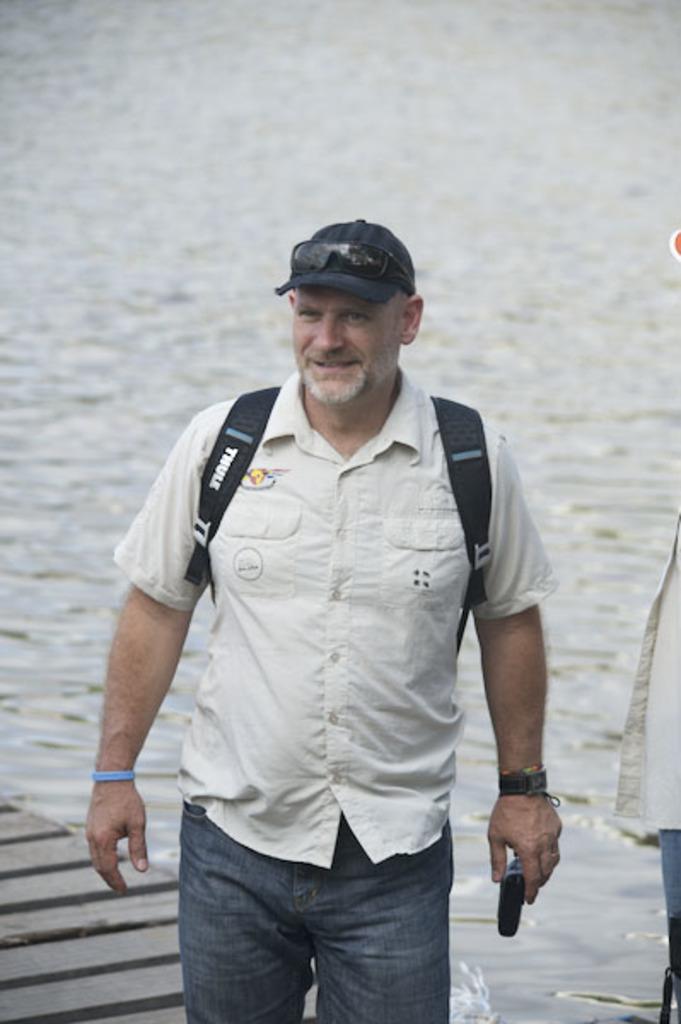In one or two sentences, can you explain what this image depicts? In this image in the front there is man standing and smiling and holding an object which is black in colour and wearing a bag and a hat and on the hat there is google. In the background there is water and there is a path. On the right side there is a person. 